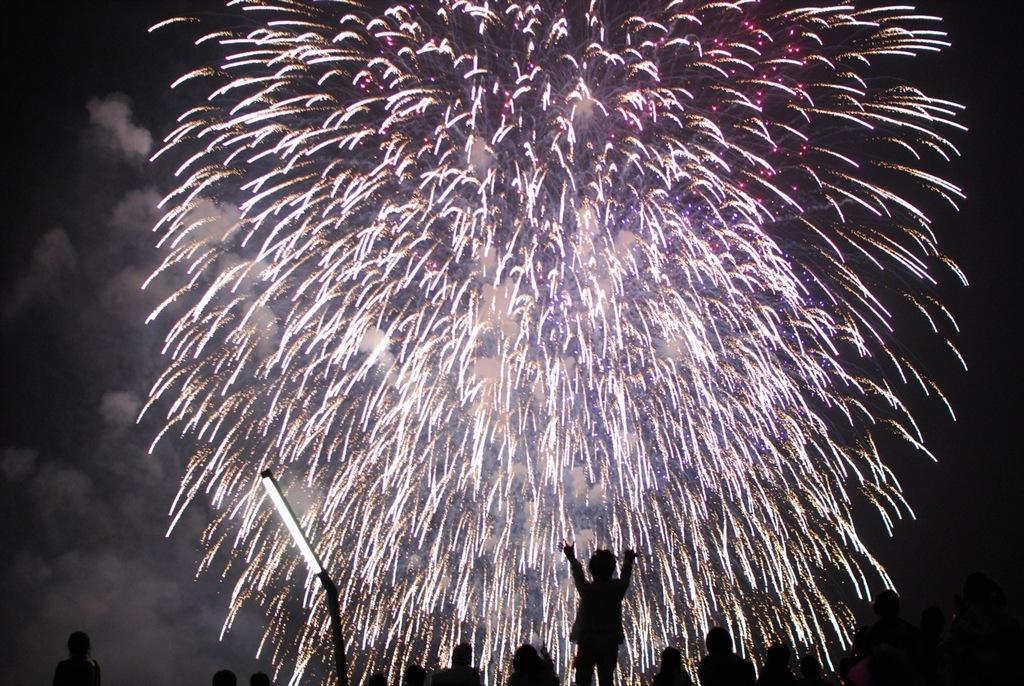Describe this image in one or two sentences. In this image I can see people, a light, sparkles over here and I can see this image is little bit in dark. 